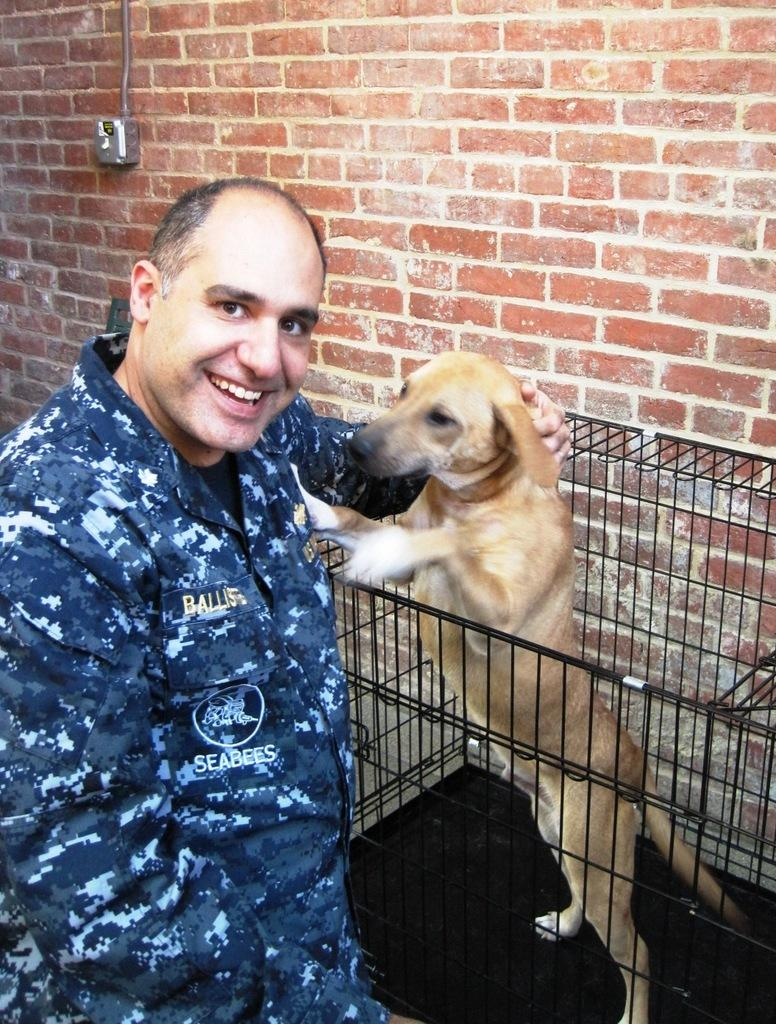What is the main subject of the image? There is a person in the image. What is the person wearing? The person is wearing a uniform. What is the person doing in the image? The person is standing and smiling. What can be seen in the cage in the image? There is a dog in a cage in the image. What is visible in the background of the image? There is a brick wall in the background of the image. What type of water is being discussed by the person in the image? There is no discussion about water in the image; the person is standing and smiling. How many eyes does the person have in the image? The person has two eyes in the image, but this question is unnecessary as it does not add any relevant information about the image. 